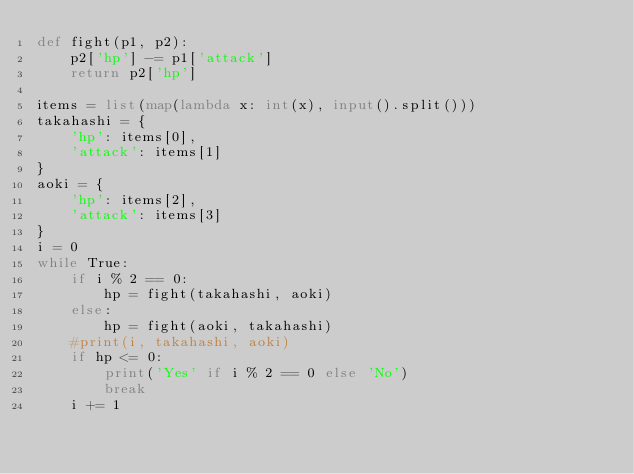<code> <loc_0><loc_0><loc_500><loc_500><_Python_>def fight(p1, p2):
    p2['hp'] -= p1['attack']
    return p2['hp']

items = list(map(lambda x: int(x), input().split()))
takahashi = {
    'hp': items[0],
    'attack': items[1]
}
aoki = {
    'hp': items[2],
    'attack': items[3]
}
i = 0
while True:
    if i % 2 == 0:
        hp = fight(takahashi, aoki)
    else:
        hp = fight(aoki, takahashi)
    #print(i, takahashi, aoki)
    if hp <= 0:
        print('Yes' if i % 2 == 0 else 'No')
        break
    i += 1</code> 